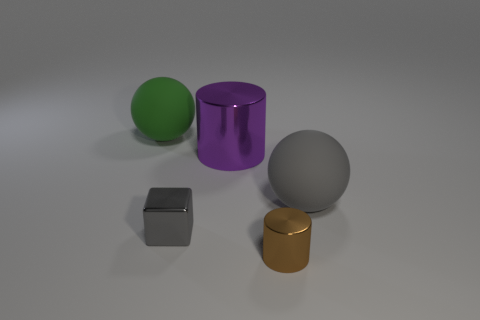What is the color of the rubber sphere that is to the right of the small brown cylinder that is in front of the matte object that is to the right of the tiny gray metallic thing?
Make the answer very short. Gray. What number of things are large spheres to the left of the small brown thing or large cyan matte cylinders?
Provide a succinct answer. 1. There is a thing that is the same size as the metal block; what is its material?
Your answer should be very brief. Metal. What is the material of the cylinder in front of the sphere that is right of the green thing to the left of the small brown metallic thing?
Keep it short and to the point. Metal. The small metallic cube is what color?
Give a very brief answer. Gray. What number of large things are either purple cylinders or matte spheres?
Provide a succinct answer. 3. There is a sphere that is the same color as the block; what material is it?
Offer a terse response. Rubber. Does the ball left of the tiny brown metallic thing have the same material as the large ball on the right side of the brown cylinder?
Give a very brief answer. Yes. Are any tiny cyan rubber cylinders visible?
Make the answer very short. No. Are there more big cylinders that are left of the shiny cube than large rubber spheres left of the small metal cylinder?
Provide a short and direct response. No. 